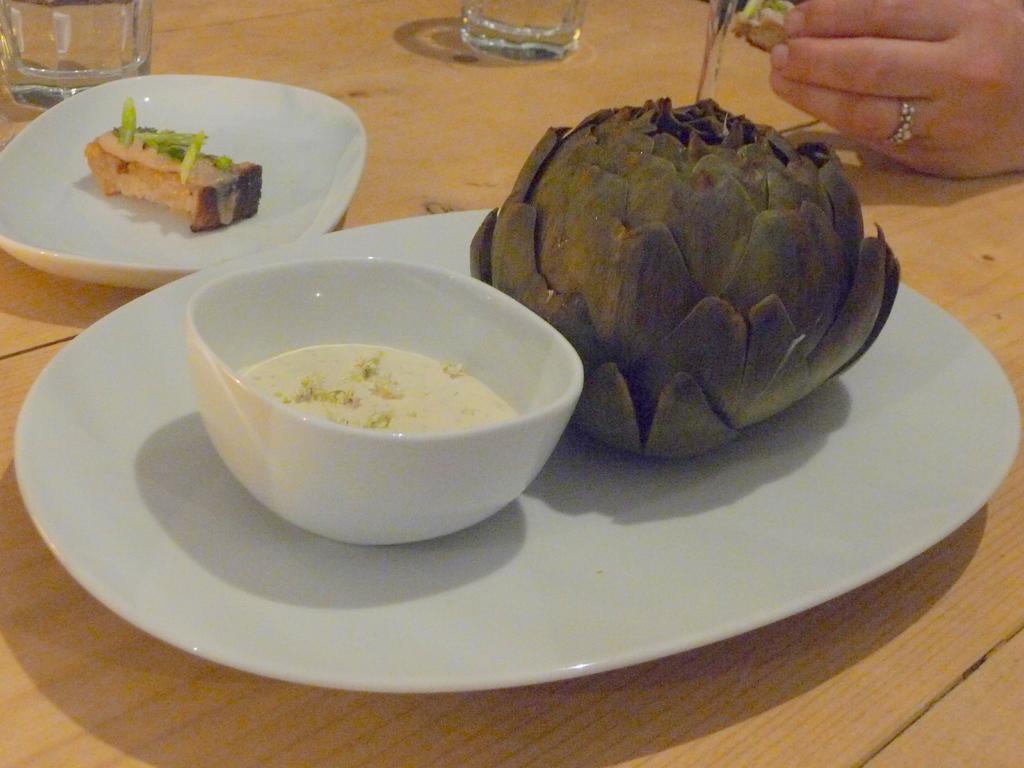Could you give a brief overview of what you see in this image? In this image I can see food items in white plate and there is a bowl. There is hand of a person on the right. There are glasses at the back. 